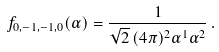<formula> <loc_0><loc_0><loc_500><loc_500>f _ { 0 , - 1 , - 1 , 0 } ( \alpha ) = \frac { 1 } { \sqrt { 2 } \, ( 4 \pi ) ^ { 2 } \alpha ^ { 1 } \alpha ^ { 2 } } \, .</formula> 